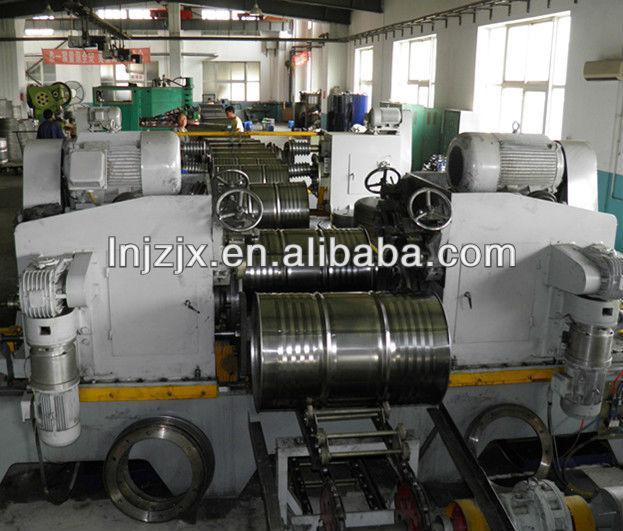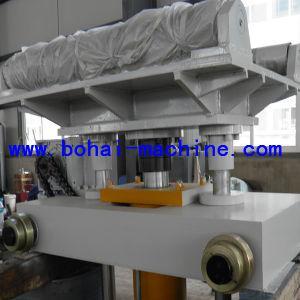The first image is the image on the left, the second image is the image on the right. For the images displayed, is the sentence "An image shows silver barrels on their sides flanked by greenish-bluish painted equipment, and a man in a blue shirt on the far right." factually correct? Answer yes or no. No. 